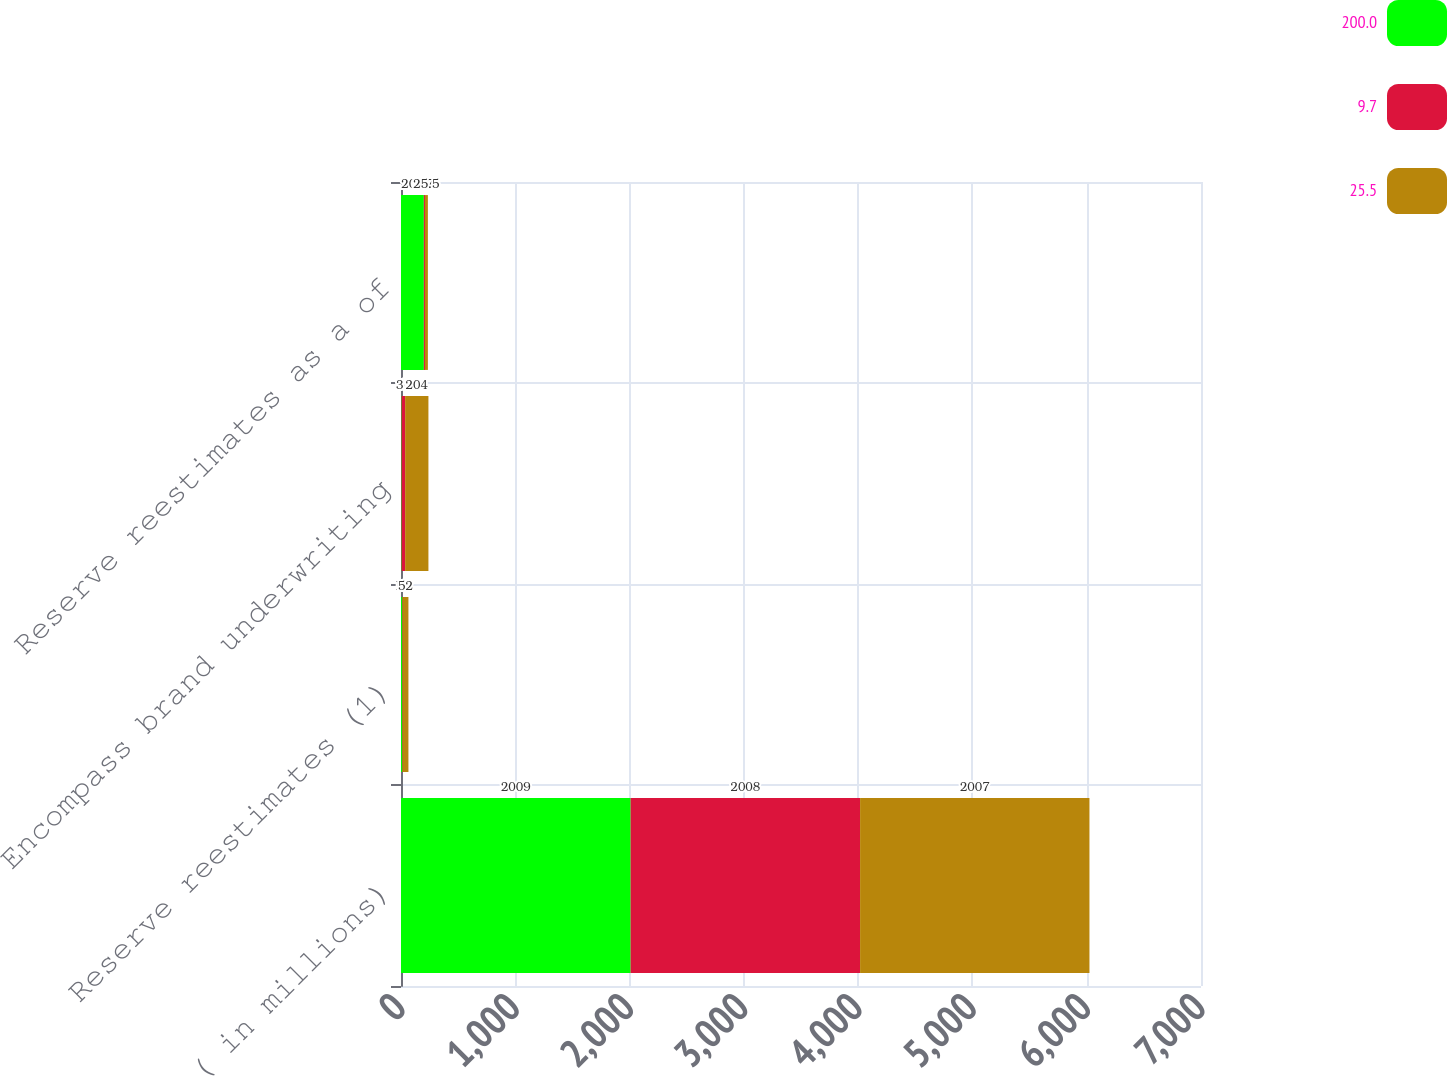<chart> <loc_0><loc_0><loc_500><loc_500><stacked_bar_chart><ecel><fcel>( in millions)<fcel>Reserve reestimates (1)<fcel>Encompass brand underwriting<fcel>Reserve reestimates as a of<nl><fcel>200<fcel>2009<fcel>10<fcel>5<fcel>200<nl><fcel>9.7<fcel>2008<fcel>3<fcel>31<fcel>9.7<nl><fcel>25.5<fcel>2007<fcel>52<fcel>204<fcel>25.5<nl></chart> 